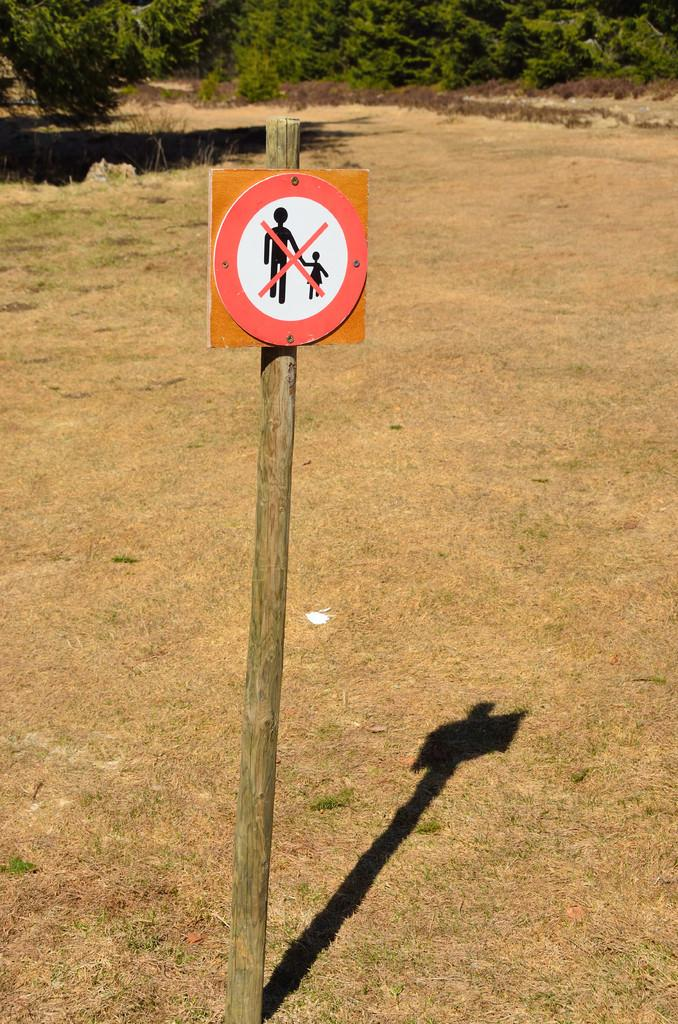What is on the wooden pole in the image? There is a sign board on a wooden pole in the image. What can be seen in the background of the image? There are trees in the background of the image. What type of vegetation is on the ground in the image? There is grass on the ground in the image. How many toes are visible on the sign board in the image? There are no toes present on the sign board in the image. What type of party is being held in the background of the image? There is no party visible in the image; it only shows a sign board on a wooden pole, trees in the background, and grass on the ground. 